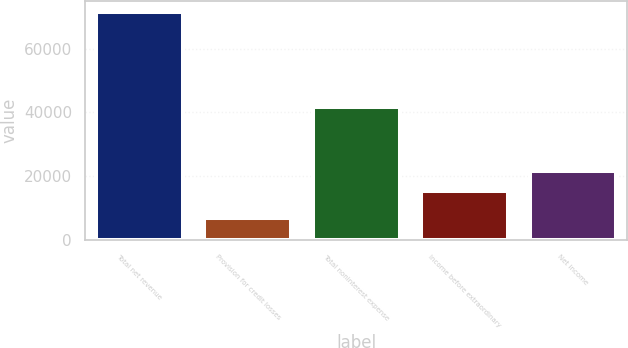Convert chart. <chart><loc_0><loc_0><loc_500><loc_500><bar_chart><fcel>Total net revenue<fcel>Provision for credit losses<fcel>Total noninterest expense<fcel>Income before extraordinary<fcel>Net income<nl><fcel>71372<fcel>6864<fcel>41703<fcel>15365<fcel>21815.8<nl></chart> 